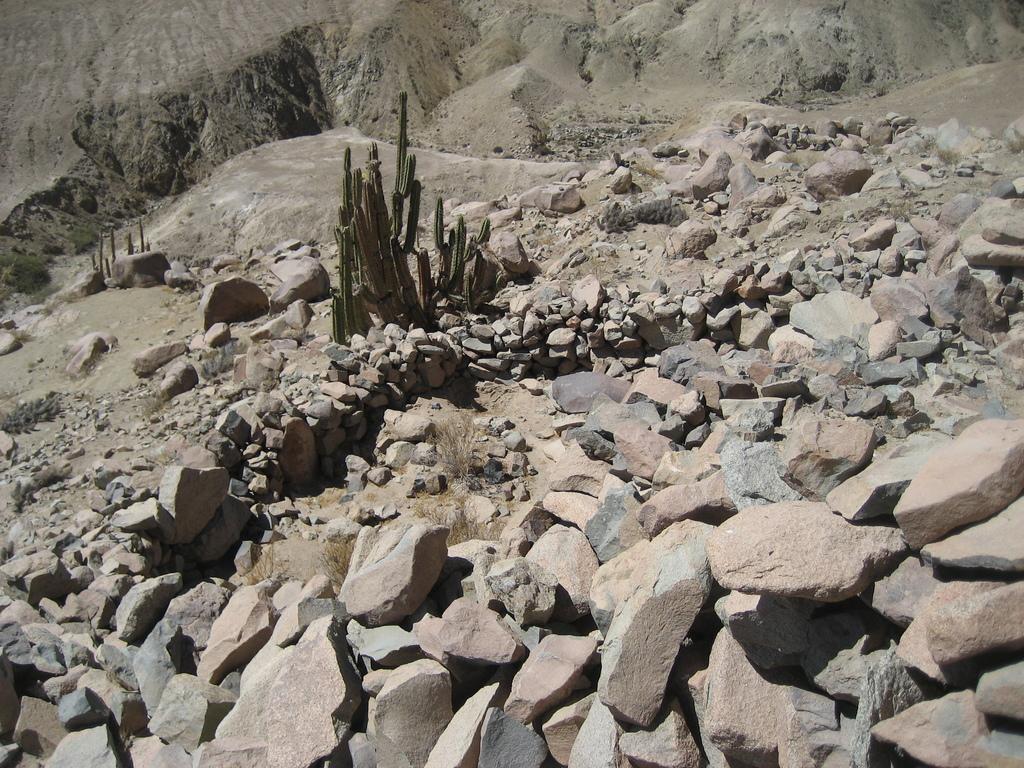Please provide a concise description of this image. In this image we can see there are cactus plant on the surface of the rocks. In the background there is a mountain. 